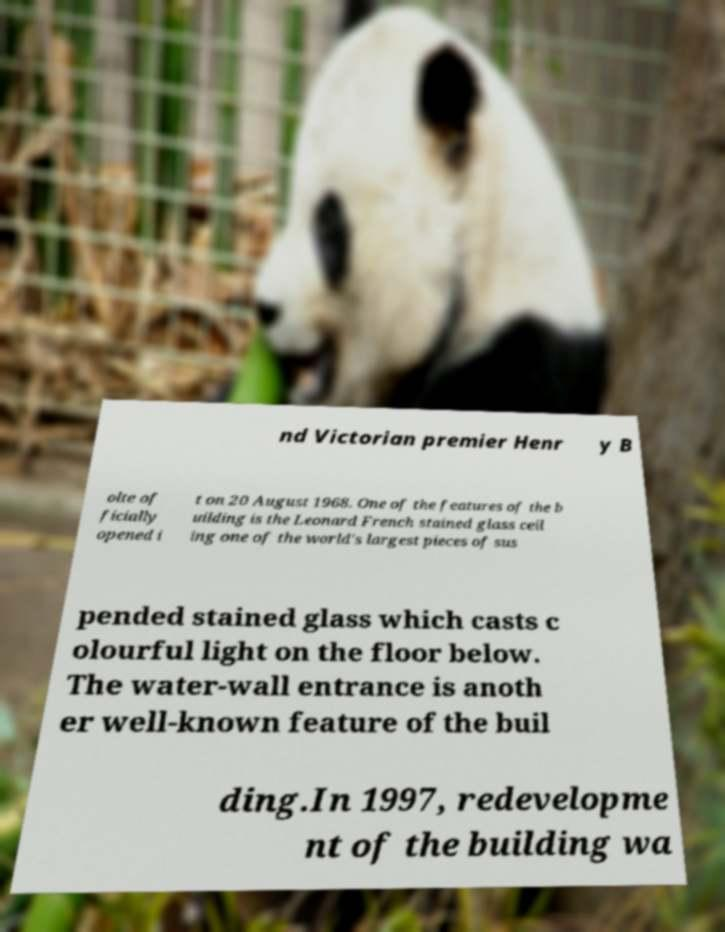For documentation purposes, I need the text within this image transcribed. Could you provide that? nd Victorian premier Henr y B olte of ficially opened i t on 20 August 1968. One of the features of the b uilding is the Leonard French stained glass ceil ing one of the world's largest pieces of sus pended stained glass which casts c olourful light on the floor below. The water-wall entrance is anoth er well-known feature of the buil ding.In 1997, redevelopme nt of the building wa 